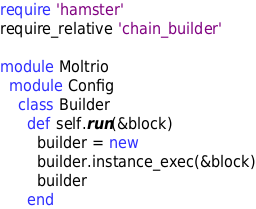<code> <loc_0><loc_0><loc_500><loc_500><_Ruby_>require 'hamster'
require_relative 'chain_builder'

module Moltrio
  module Config
    class Builder
      def self.run(&block)
        builder = new
        builder.instance_exec(&block)
        builder
      end
</code> 